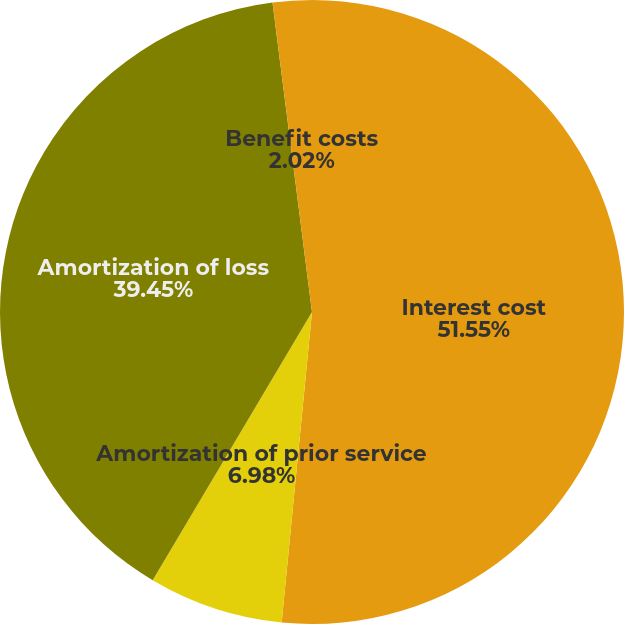<chart> <loc_0><loc_0><loc_500><loc_500><pie_chart><fcel>Interest cost<fcel>Amortization of prior service<fcel>Amortization of loss<fcel>Benefit costs<nl><fcel>51.55%<fcel>6.98%<fcel>39.45%<fcel>2.02%<nl></chart> 